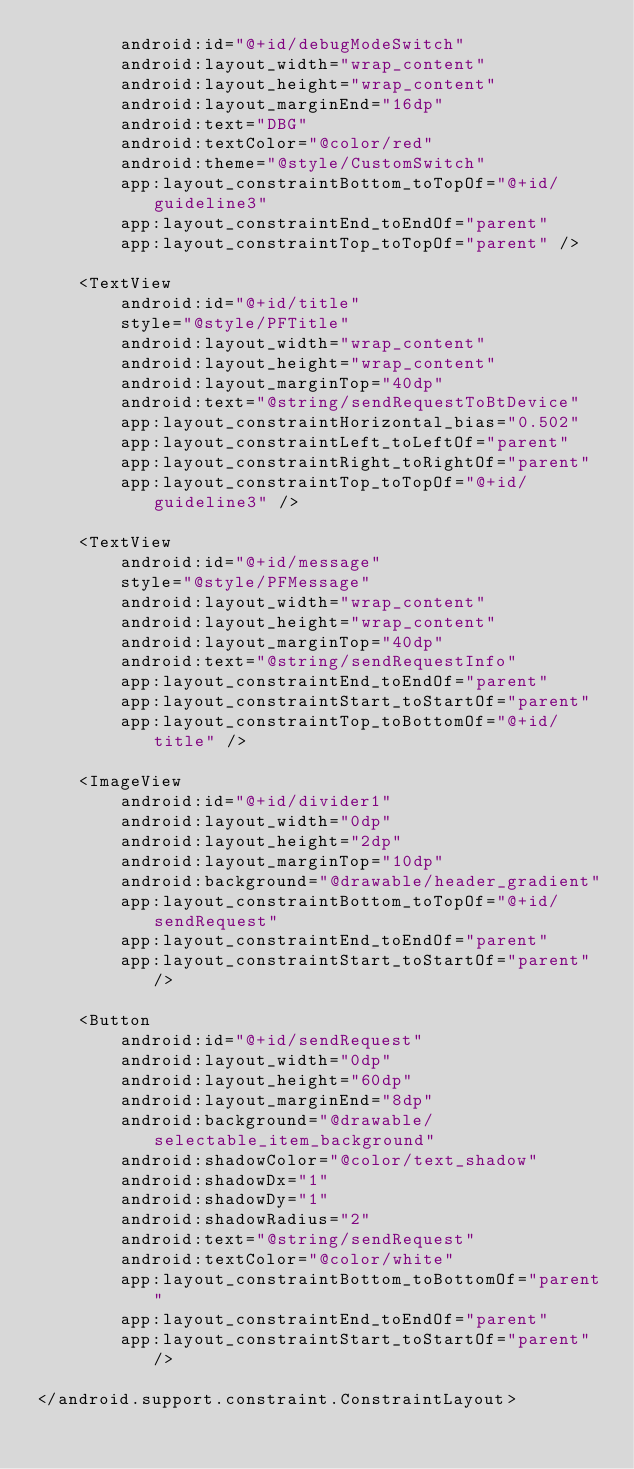<code> <loc_0><loc_0><loc_500><loc_500><_XML_>        android:id="@+id/debugModeSwitch"
        android:layout_width="wrap_content"
        android:layout_height="wrap_content"
        android:layout_marginEnd="16dp"
        android:text="DBG"
        android:textColor="@color/red"
        android:theme="@style/CustomSwitch"
        app:layout_constraintBottom_toTopOf="@+id/guideline3"
        app:layout_constraintEnd_toEndOf="parent"
        app:layout_constraintTop_toTopOf="parent" />

    <TextView
        android:id="@+id/title"
        style="@style/PFTitle"
        android:layout_width="wrap_content"
        android:layout_height="wrap_content"
        android:layout_marginTop="40dp"
        android:text="@string/sendRequestToBtDevice"
        app:layout_constraintHorizontal_bias="0.502"
        app:layout_constraintLeft_toLeftOf="parent"
        app:layout_constraintRight_toRightOf="parent"
        app:layout_constraintTop_toTopOf="@+id/guideline3" />

    <TextView
        android:id="@+id/message"
        style="@style/PFMessage"
        android:layout_width="wrap_content"
        android:layout_height="wrap_content"
        android:layout_marginTop="40dp"
        android:text="@string/sendRequestInfo"
        app:layout_constraintEnd_toEndOf="parent"
        app:layout_constraintStart_toStartOf="parent"
        app:layout_constraintTop_toBottomOf="@+id/title" />

    <ImageView
        android:id="@+id/divider1"
        android:layout_width="0dp"
        android:layout_height="2dp"
        android:layout_marginTop="10dp"
        android:background="@drawable/header_gradient"
        app:layout_constraintBottom_toTopOf="@+id/sendRequest"
        app:layout_constraintEnd_toEndOf="parent"
        app:layout_constraintStart_toStartOf="parent" />

    <Button
        android:id="@+id/sendRequest"
        android:layout_width="0dp"
        android:layout_height="60dp"
        android:layout_marginEnd="8dp"
        android:background="@drawable/selectable_item_background"
        android:shadowColor="@color/text_shadow"
        android:shadowDx="1"
        android:shadowDy="1"
        android:shadowRadius="2"
        android:text="@string/sendRequest"
        android:textColor="@color/white"
        app:layout_constraintBottom_toBottomOf="parent"
        app:layout_constraintEnd_toEndOf="parent"
        app:layout_constraintStart_toStartOf="parent" />

</android.support.constraint.ConstraintLayout></code> 